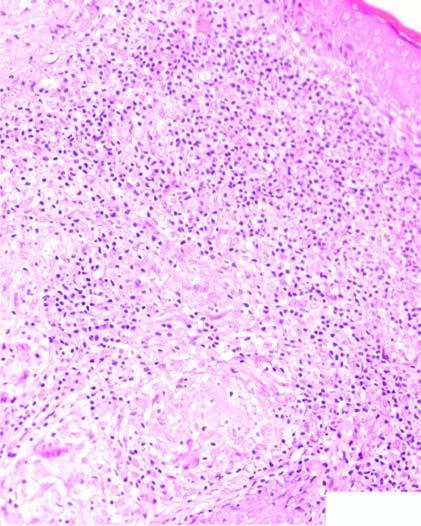what does the dermis contain?
Answer the question using a single word or phrase. Caseating epithelioid cell granulomas having giant cells and lymphocytes 